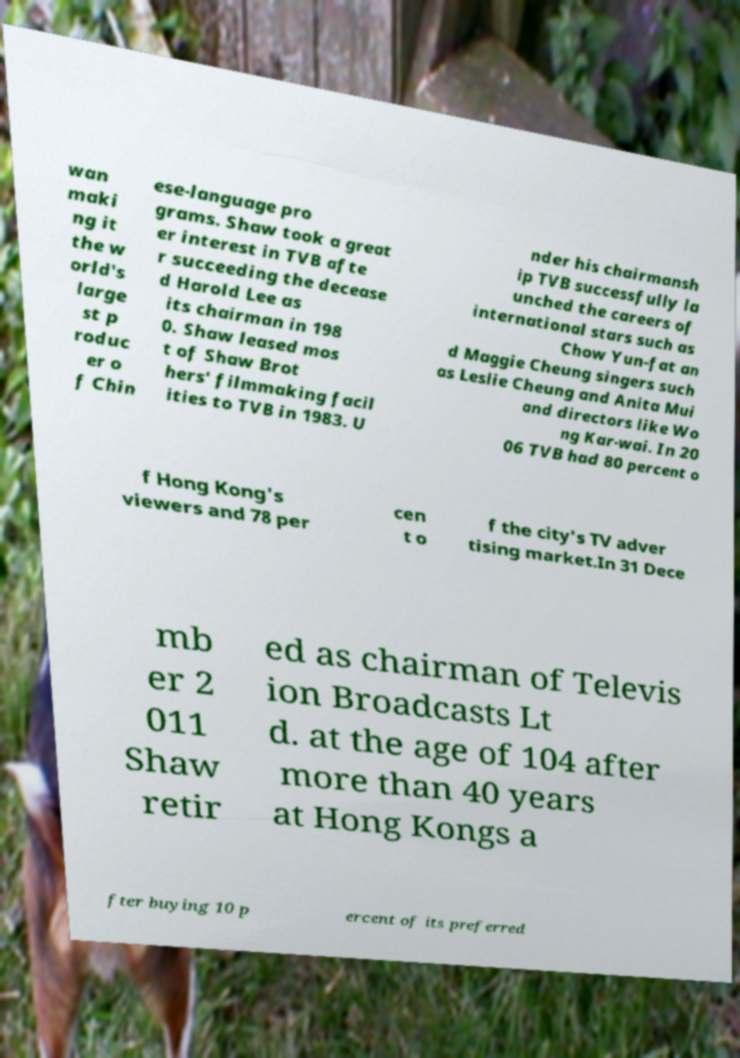Can you read and provide the text displayed in the image?This photo seems to have some interesting text. Can you extract and type it out for me? wan maki ng it the w orld's large st p roduc er o f Chin ese-language pro grams. Shaw took a great er interest in TVB afte r succeeding the decease d Harold Lee as its chairman in 198 0. Shaw leased mos t of Shaw Brot hers' filmmaking facil ities to TVB in 1983. U nder his chairmansh ip TVB successfully la unched the careers of international stars such as Chow Yun-fat an d Maggie Cheung singers such as Leslie Cheung and Anita Mui and directors like Wo ng Kar-wai. In 20 06 TVB had 80 percent o f Hong Kong's viewers and 78 per cen t o f the city's TV adver tising market.In 31 Dece mb er 2 011 Shaw retir ed as chairman of Televis ion Broadcasts Lt d. at the age of 104 after more than 40 years at Hong Kongs a fter buying 10 p ercent of its preferred 